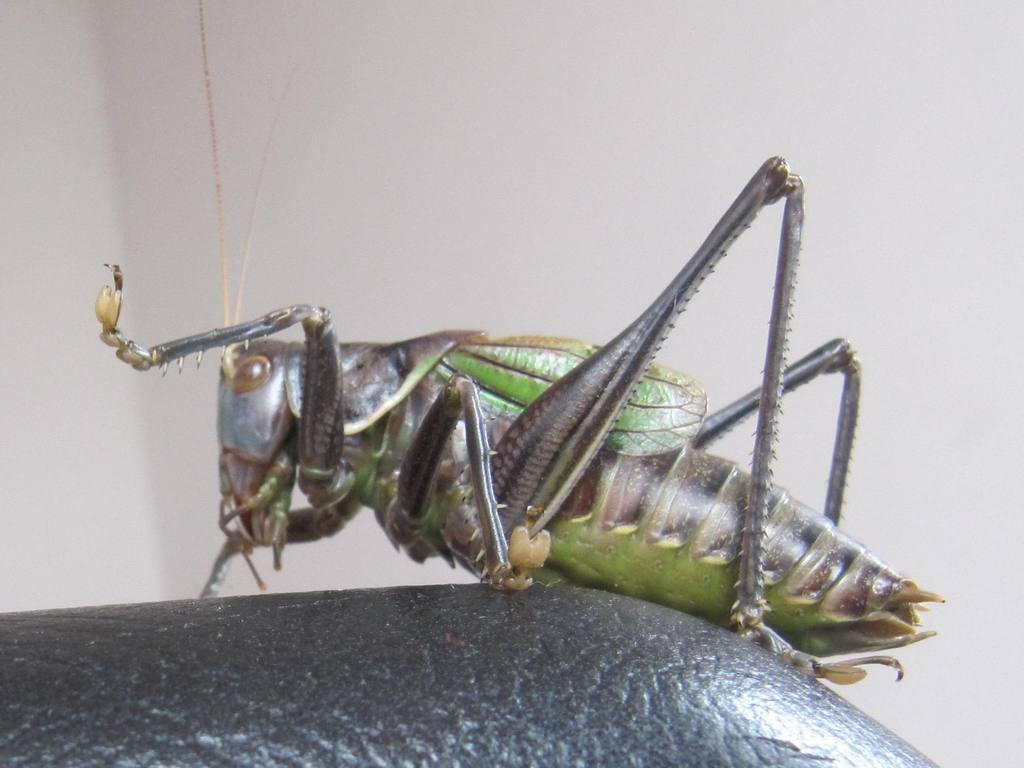What is present on the table in the image? There is an insect on the table in the image. What can be seen in the background of the image? There is a wall visible in the background of the image. What type of brass circle can be seen in the image? There is no brass circle present in the image. 